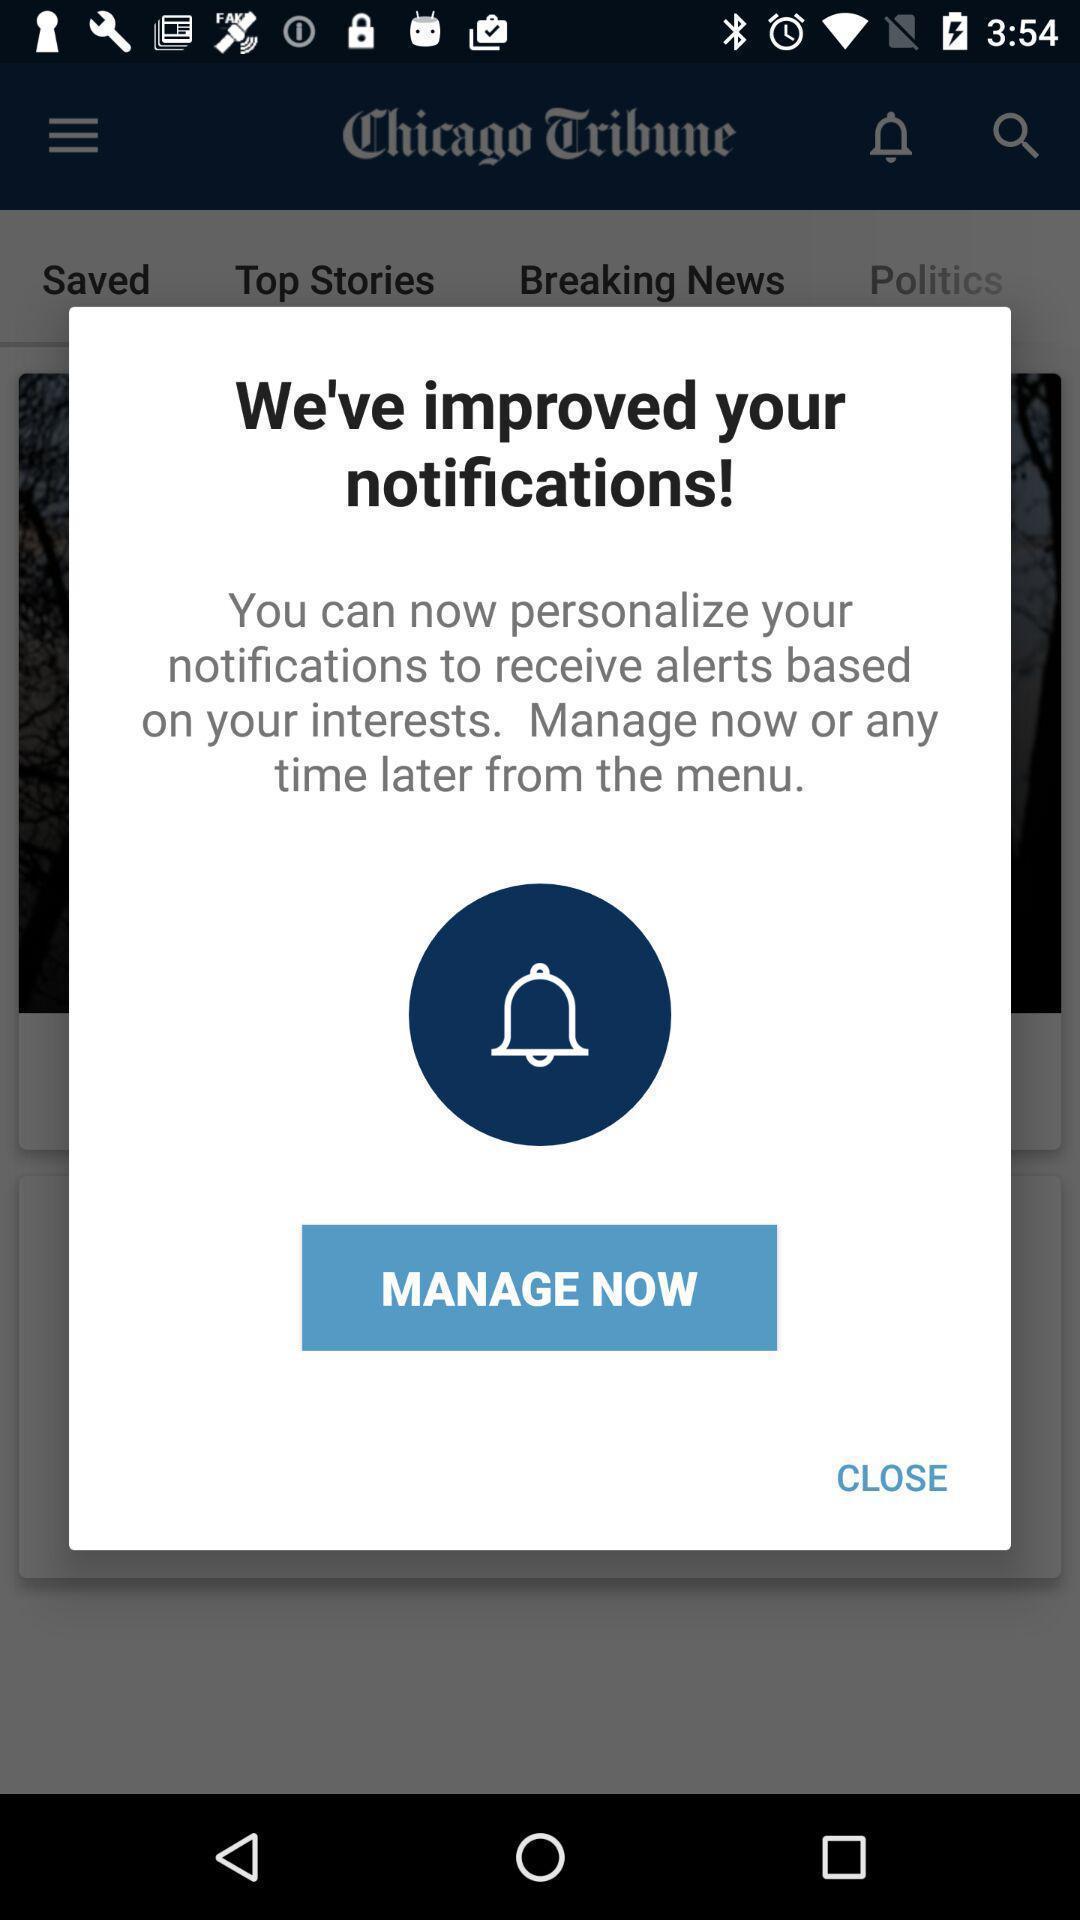Describe this image in words. Pop-up displaying the notification settings. 